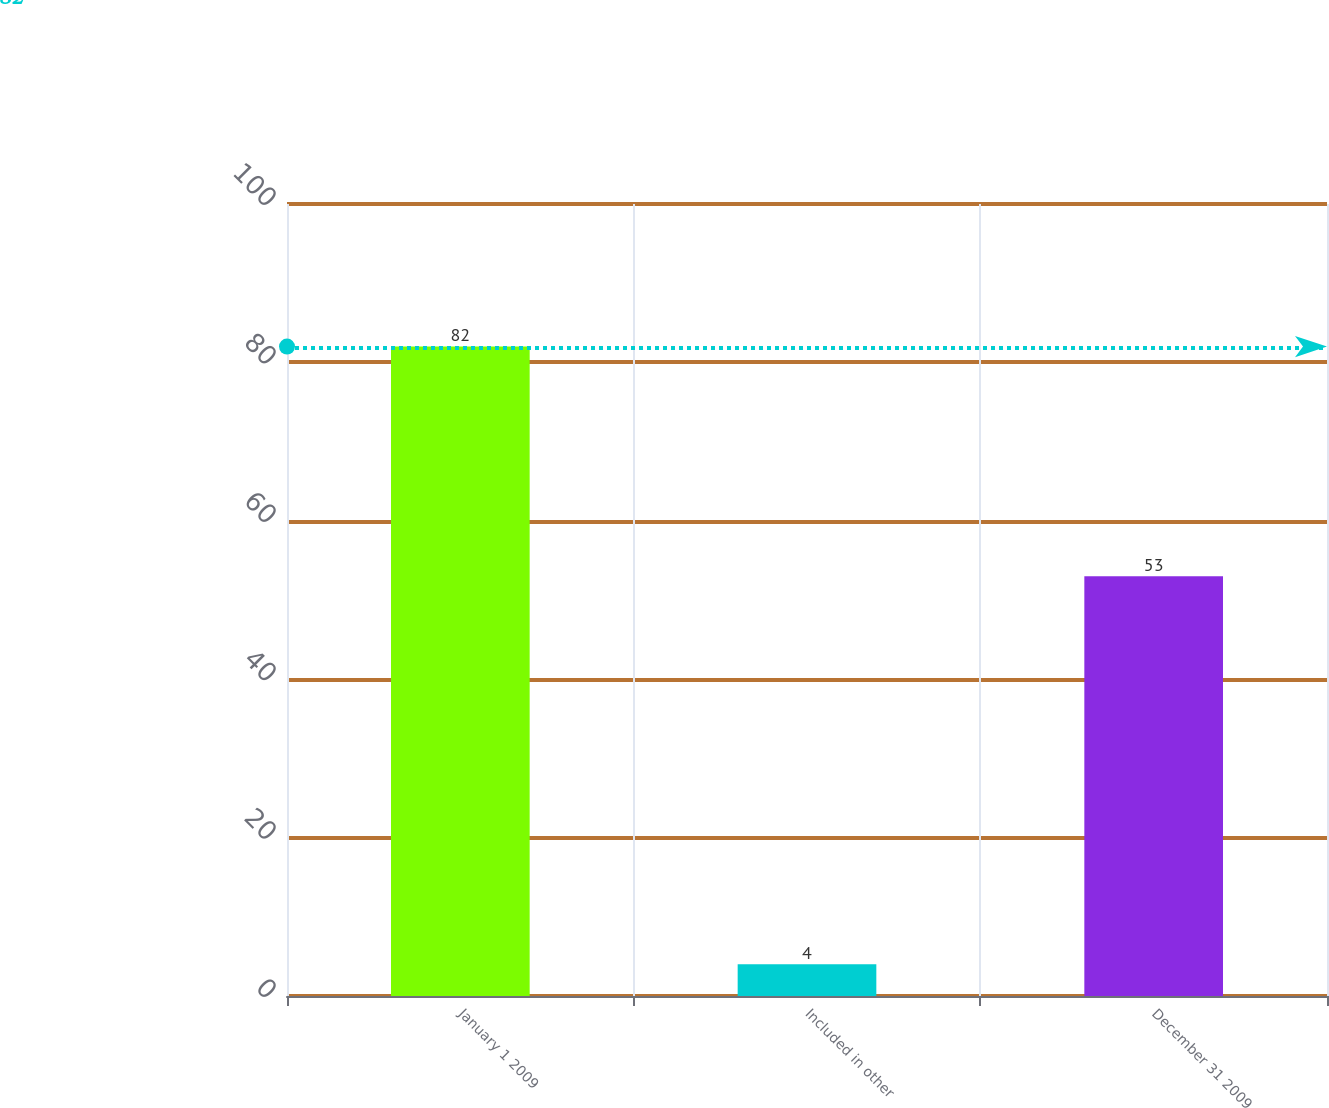Convert chart. <chart><loc_0><loc_0><loc_500><loc_500><bar_chart><fcel>January 1 2009<fcel>Included in other<fcel>December 31 2009<nl><fcel>82<fcel>4<fcel>53<nl></chart> 